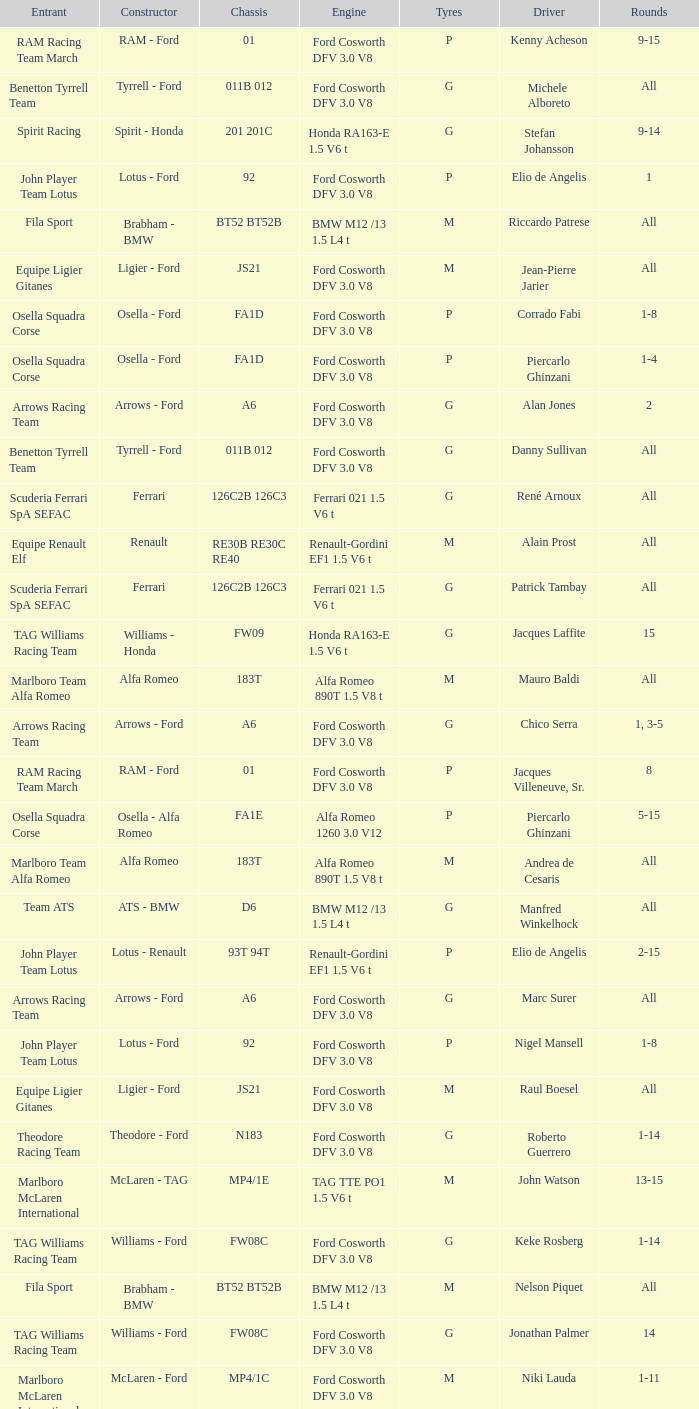Who is driver of the d6 chassis? Manfred Winkelhock. 